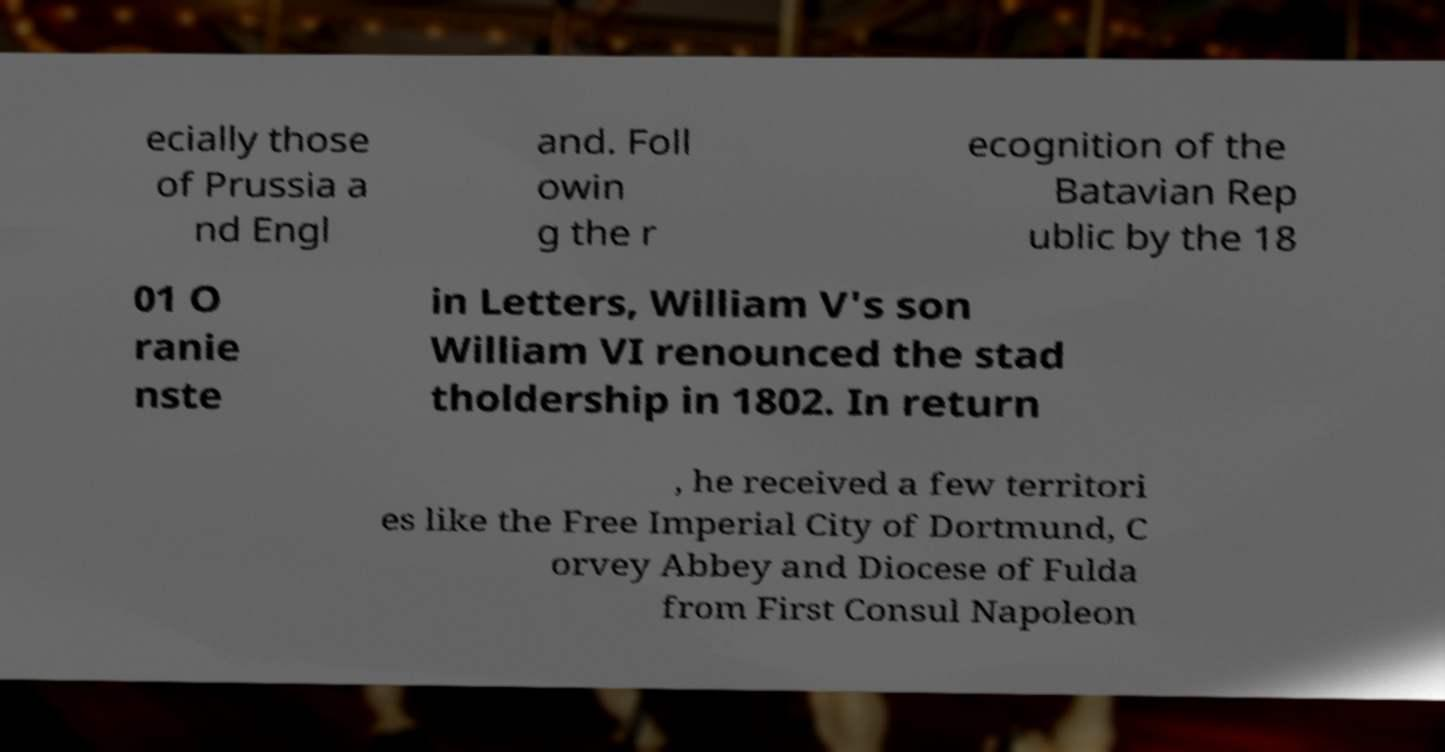I need the written content from this picture converted into text. Can you do that? ecially those of Prussia a nd Engl and. Foll owin g the r ecognition of the Batavian Rep ublic by the 18 01 O ranie nste in Letters, William V's son William VI renounced the stad tholdership in 1802. In return , he received a few territori es like the Free Imperial City of Dortmund, C orvey Abbey and Diocese of Fulda from First Consul Napoleon 